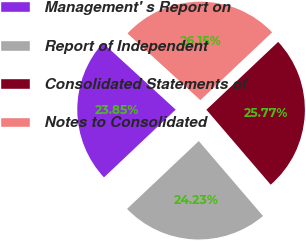<chart> <loc_0><loc_0><loc_500><loc_500><pie_chart><fcel>Management' s Report on<fcel>Report of Independent<fcel>Consolidated Statements of<fcel>Notes to Consolidated<nl><fcel>23.85%<fcel>24.23%<fcel>25.77%<fcel>26.15%<nl></chart> 